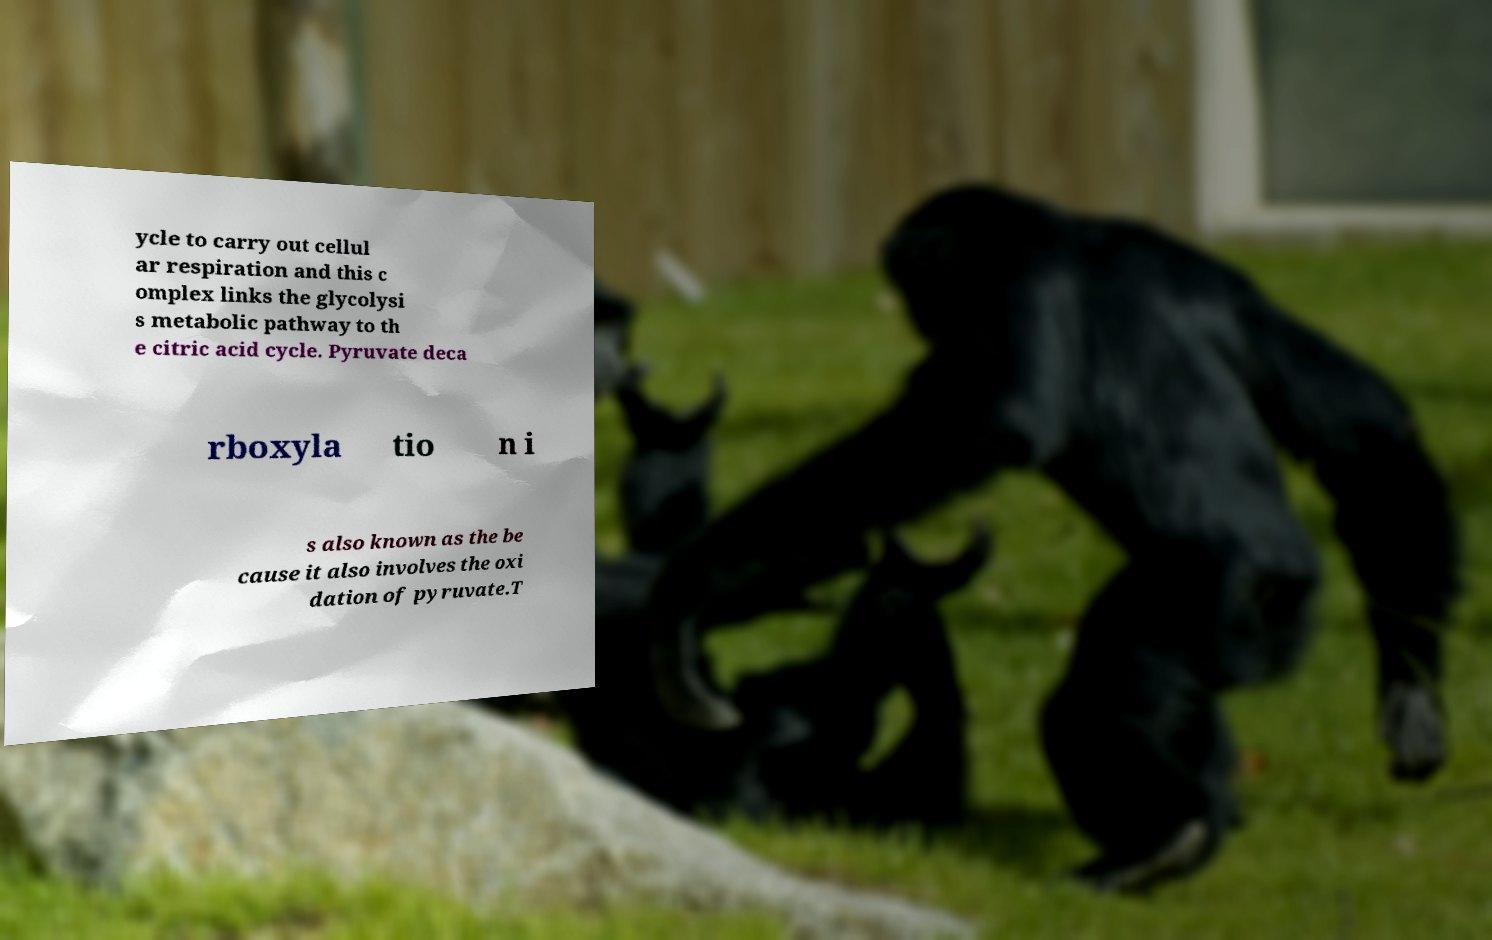Can you accurately transcribe the text from the provided image for me? ycle to carry out cellul ar respiration and this c omplex links the glycolysi s metabolic pathway to th e citric acid cycle. Pyruvate deca rboxyla tio n i s also known as the be cause it also involves the oxi dation of pyruvate.T 